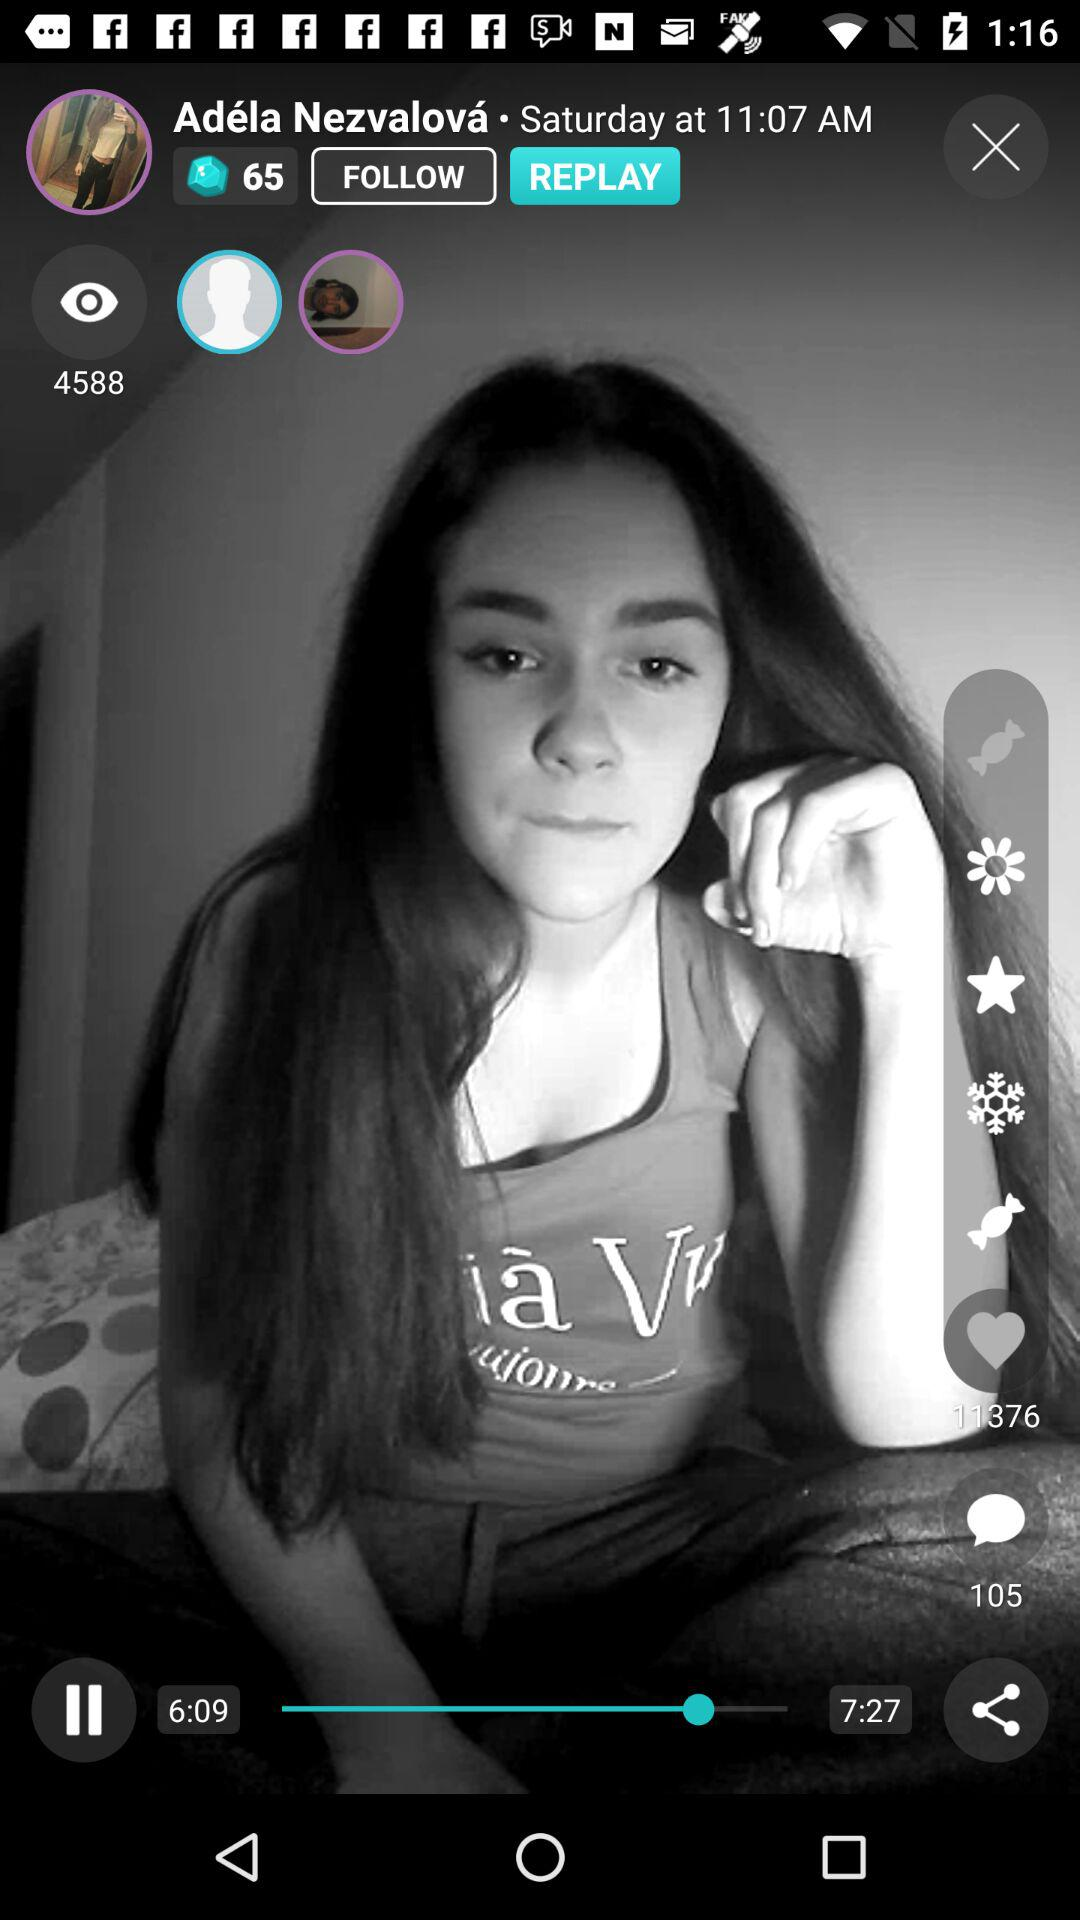How many likes are there?
When the provided information is insufficient, respond with <no answer>. <no answer> 